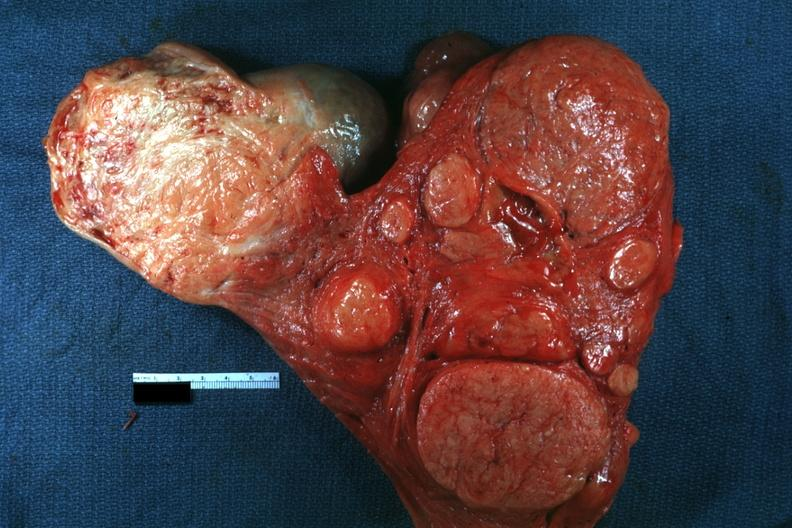where does this belong to?
Answer the question using a single word or phrase. Female reproductive system 